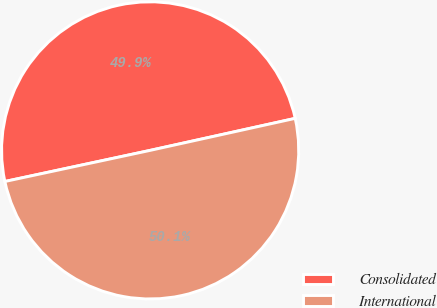<chart> <loc_0><loc_0><loc_500><loc_500><pie_chart><fcel>Consolidated<fcel>International<nl><fcel>49.9%<fcel>50.1%<nl></chart> 